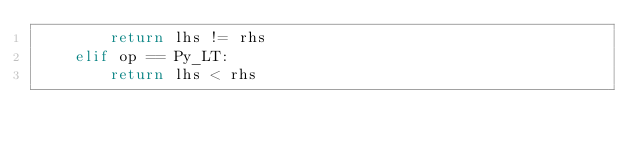<code> <loc_0><loc_0><loc_500><loc_500><_Cython_>        return lhs != rhs
    elif op == Py_LT:
        return lhs < rhs</code> 